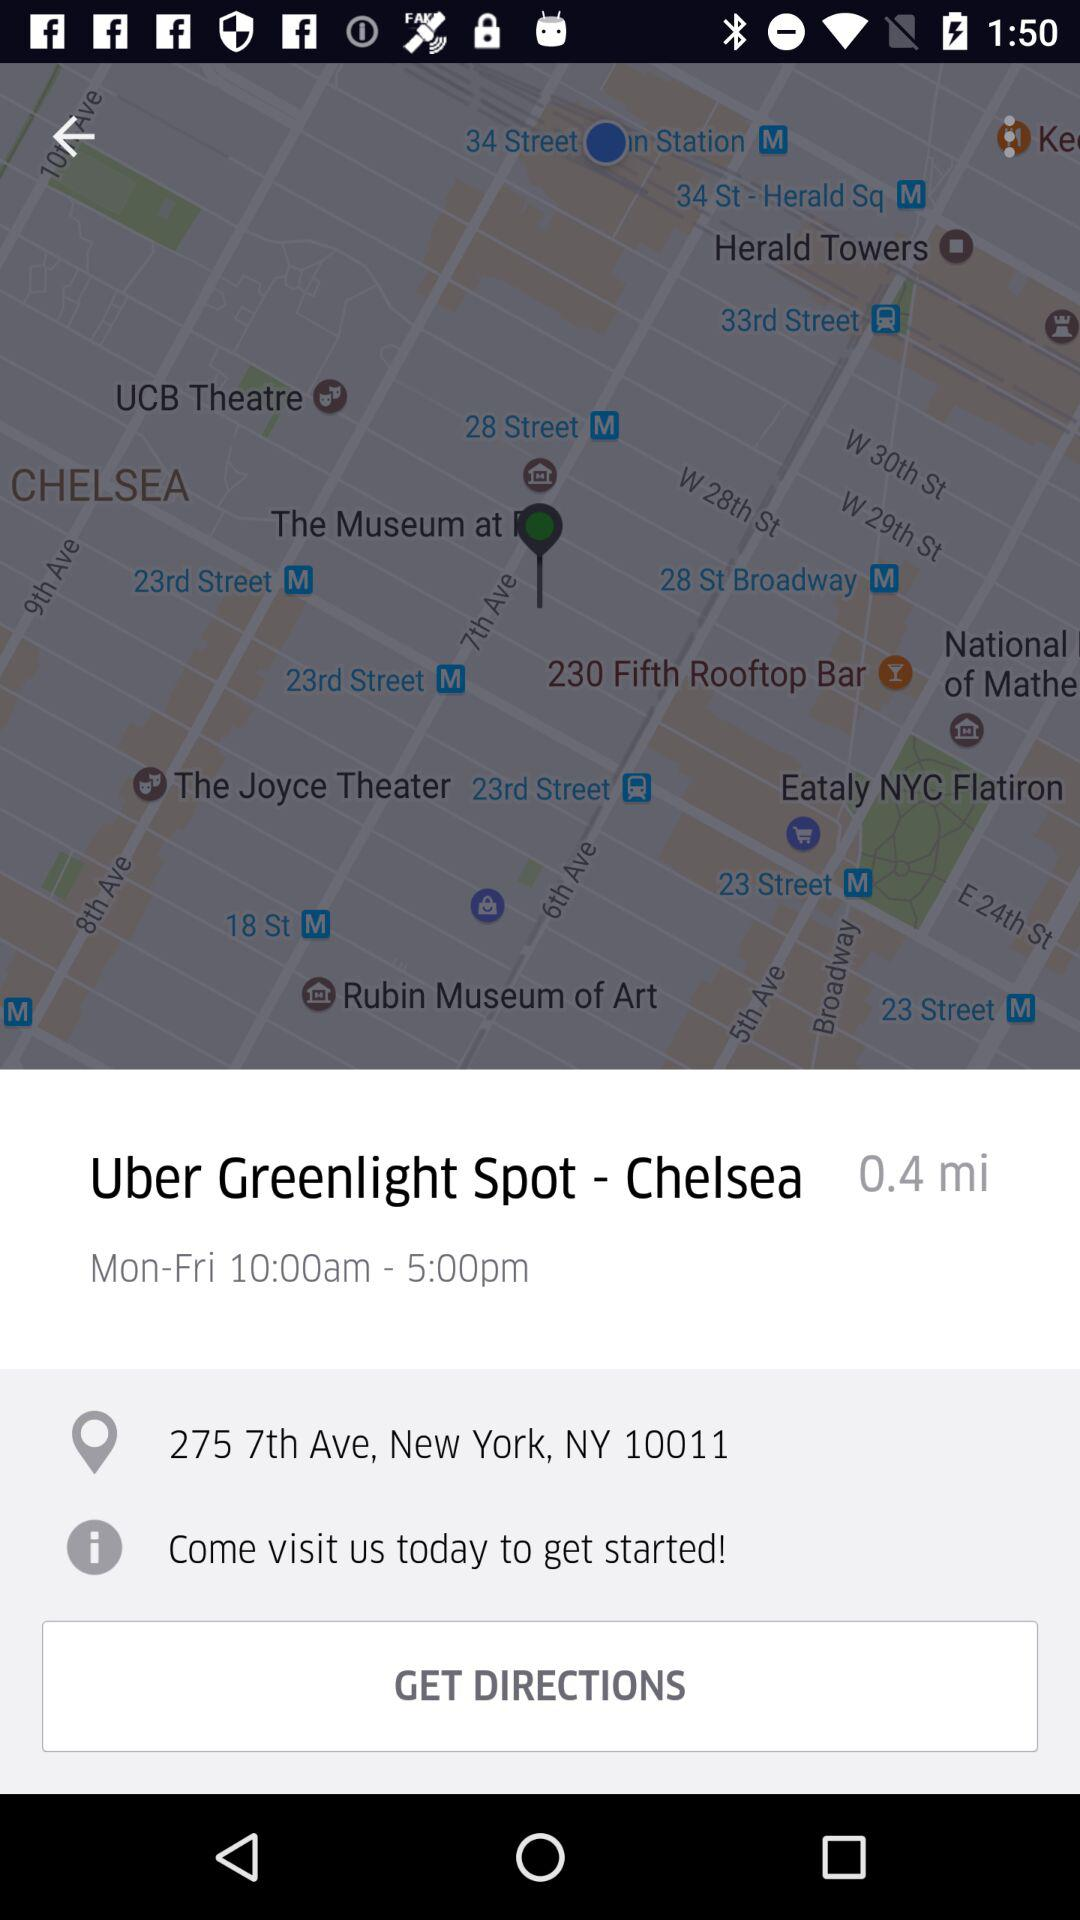What is the location? The location is 275 7th Ave, New York, NY 10011. 